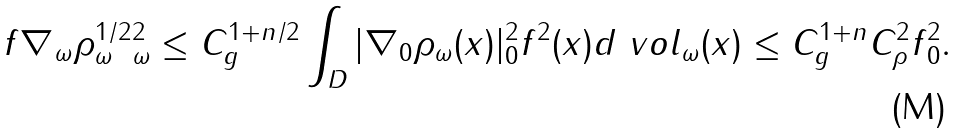<formula> <loc_0><loc_0><loc_500><loc_500>\| f \nabla _ { \omega } \rho _ { \omega } ^ { 1 / 2 } \| _ { \omega } ^ { 2 } \leq C _ { g } ^ { 1 + n / 2 } \int _ { D } | \nabla _ { 0 } \rho _ { \omega } ( x ) | _ { 0 } ^ { 2 } f ^ { 2 } ( x ) d \ v o l _ { \omega } ( x ) \leq C _ { g } ^ { 1 + n } C _ { \rho } ^ { 2 } \| f \| ^ { 2 } _ { 0 } .</formula> 